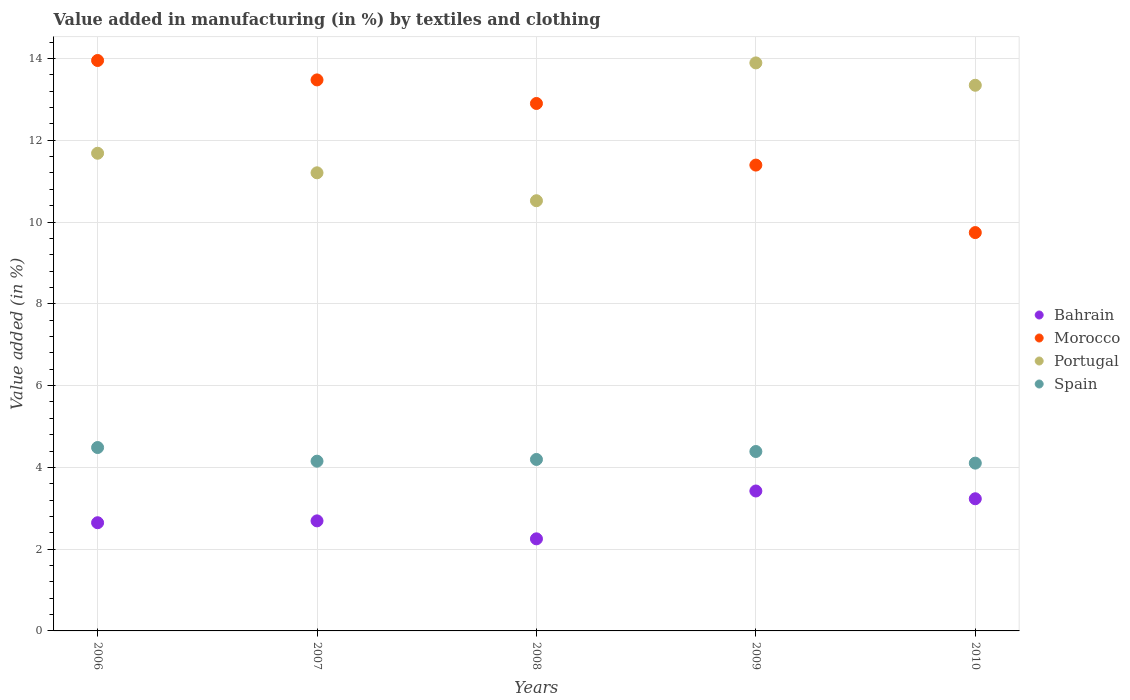Is the number of dotlines equal to the number of legend labels?
Provide a succinct answer. Yes. What is the percentage of value added in manufacturing by textiles and clothing in Portugal in 2009?
Ensure brevity in your answer.  13.89. Across all years, what is the maximum percentage of value added in manufacturing by textiles and clothing in Morocco?
Your answer should be very brief. 13.95. Across all years, what is the minimum percentage of value added in manufacturing by textiles and clothing in Morocco?
Offer a very short reply. 9.74. In which year was the percentage of value added in manufacturing by textiles and clothing in Bahrain maximum?
Give a very brief answer. 2009. In which year was the percentage of value added in manufacturing by textiles and clothing in Portugal minimum?
Your answer should be compact. 2008. What is the total percentage of value added in manufacturing by textiles and clothing in Spain in the graph?
Ensure brevity in your answer.  21.32. What is the difference between the percentage of value added in manufacturing by textiles and clothing in Bahrain in 2006 and that in 2009?
Your answer should be compact. -0.78. What is the difference between the percentage of value added in manufacturing by textiles and clothing in Spain in 2007 and the percentage of value added in manufacturing by textiles and clothing in Morocco in 2008?
Your answer should be very brief. -8.75. What is the average percentage of value added in manufacturing by textiles and clothing in Morocco per year?
Your response must be concise. 12.29. In the year 2006, what is the difference between the percentage of value added in manufacturing by textiles and clothing in Spain and percentage of value added in manufacturing by textiles and clothing in Morocco?
Provide a succinct answer. -9.46. In how many years, is the percentage of value added in manufacturing by textiles and clothing in Portugal greater than 5.2 %?
Offer a terse response. 5. What is the ratio of the percentage of value added in manufacturing by textiles and clothing in Portugal in 2008 to that in 2010?
Provide a succinct answer. 0.79. Is the percentage of value added in manufacturing by textiles and clothing in Bahrain in 2006 less than that in 2009?
Provide a succinct answer. Yes. What is the difference between the highest and the second highest percentage of value added in manufacturing by textiles and clothing in Morocco?
Offer a very short reply. 0.47. What is the difference between the highest and the lowest percentage of value added in manufacturing by textiles and clothing in Portugal?
Your answer should be compact. 3.37. Is it the case that in every year, the sum of the percentage of value added in manufacturing by textiles and clothing in Spain and percentage of value added in manufacturing by textiles and clothing in Portugal  is greater than the sum of percentage of value added in manufacturing by textiles and clothing in Bahrain and percentage of value added in manufacturing by textiles and clothing in Morocco?
Give a very brief answer. No. Does the percentage of value added in manufacturing by textiles and clothing in Bahrain monotonically increase over the years?
Provide a short and direct response. No. Is the percentage of value added in manufacturing by textiles and clothing in Spain strictly greater than the percentage of value added in manufacturing by textiles and clothing in Bahrain over the years?
Ensure brevity in your answer.  Yes. Does the graph contain grids?
Your answer should be compact. Yes. Where does the legend appear in the graph?
Your response must be concise. Center right. What is the title of the graph?
Provide a short and direct response. Value added in manufacturing (in %) by textiles and clothing. Does "Least developed countries" appear as one of the legend labels in the graph?
Provide a succinct answer. No. What is the label or title of the X-axis?
Make the answer very short. Years. What is the label or title of the Y-axis?
Your answer should be very brief. Value added (in %). What is the Value added (in %) in Bahrain in 2006?
Ensure brevity in your answer.  2.65. What is the Value added (in %) in Morocco in 2006?
Provide a short and direct response. 13.95. What is the Value added (in %) of Portugal in 2006?
Ensure brevity in your answer.  11.68. What is the Value added (in %) in Spain in 2006?
Your answer should be compact. 4.49. What is the Value added (in %) in Bahrain in 2007?
Ensure brevity in your answer.  2.69. What is the Value added (in %) in Morocco in 2007?
Keep it short and to the point. 13.48. What is the Value added (in %) in Portugal in 2007?
Make the answer very short. 11.2. What is the Value added (in %) of Spain in 2007?
Keep it short and to the point. 4.15. What is the Value added (in %) of Bahrain in 2008?
Offer a terse response. 2.25. What is the Value added (in %) in Morocco in 2008?
Your answer should be very brief. 12.9. What is the Value added (in %) of Portugal in 2008?
Offer a very short reply. 10.52. What is the Value added (in %) of Spain in 2008?
Your answer should be compact. 4.19. What is the Value added (in %) of Bahrain in 2009?
Your answer should be very brief. 3.42. What is the Value added (in %) in Morocco in 2009?
Offer a very short reply. 11.39. What is the Value added (in %) in Portugal in 2009?
Offer a terse response. 13.89. What is the Value added (in %) in Spain in 2009?
Your answer should be very brief. 4.39. What is the Value added (in %) in Bahrain in 2010?
Provide a succinct answer. 3.23. What is the Value added (in %) of Morocco in 2010?
Offer a very short reply. 9.74. What is the Value added (in %) of Portugal in 2010?
Make the answer very short. 13.34. What is the Value added (in %) in Spain in 2010?
Your answer should be very brief. 4.1. Across all years, what is the maximum Value added (in %) of Bahrain?
Make the answer very short. 3.42. Across all years, what is the maximum Value added (in %) of Morocco?
Offer a very short reply. 13.95. Across all years, what is the maximum Value added (in %) of Portugal?
Your answer should be compact. 13.89. Across all years, what is the maximum Value added (in %) in Spain?
Ensure brevity in your answer.  4.49. Across all years, what is the minimum Value added (in %) of Bahrain?
Make the answer very short. 2.25. Across all years, what is the minimum Value added (in %) in Morocco?
Offer a very short reply. 9.74. Across all years, what is the minimum Value added (in %) of Portugal?
Give a very brief answer. 10.52. Across all years, what is the minimum Value added (in %) of Spain?
Offer a terse response. 4.1. What is the total Value added (in %) in Bahrain in the graph?
Make the answer very short. 14.24. What is the total Value added (in %) in Morocco in the graph?
Offer a terse response. 61.46. What is the total Value added (in %) in Portugal in the graph?
Make the answer very short. 60.64. What is the total Value added (in %) in Spain in the graph?
Offer a very short reply. 21.32. What is the difference between the Value added (in %) of Bahrain in 2006 and that in 2007?
Provide a succinct answer. -0.05. What is the difference between the Value added (in %) in Morocco in 2006 and that in 2007?
Make the answer very short. 0.47. What is the difference between the Value added (in %) in Portugal in 2006 and that in 2007?
Your answer should be compact. 0.48. What is the difference between the Value added (in %) of Spain in 2006 and that in 2007?
Give a very brief answer. 0.33. What is the difference between the Value added (in %) of Bahrain in 2006 and that in 2008?
Offer a terse response. 0.39. What is the difference between the Value added (in %) of Morocco in 2006 and that in 2008?
Offer a terse response. 1.05. What is the difference between the Value added (in %) of Portugal in 2006 and that in 2008?
Offer a very short reply. 1.16. What is the difference between the Value added (in %) of Spain in 2006 and that in 2008?
Your answer should be compact. 0.29. What is the difference between the Value added (in %) of Bahrain in 2006 and that in 2009?
Your answer should be compact. -0.78. What is the difference between the Value added (in %) in Morocco in 2006 and that in 2009?
Give a very brief answer. 2.56. What is the difference between the Value added (in %) in Portugal in 2006 and that in 2009?
Your answer should be compact. -2.21. What is the difference between the Value added (in %) of Spain in 2006 and that in 2009?
Your response must be concise. 0.1. What is the difference between the Value added (in %) of Bahrain in 2006 and that in 2010?
Your answer should be compact. -0.59. What is the difference between the Value added (in %) in Morocco in 2006 and that in 2010?
Provide a succinct answer. 4.21. What is the difference between the Value added (in %) of Portugal in 2006 and that in 2010?
Your answer should be very brief. -1.66. What is the difference between the Value added (in %) of Spain in 2006 and that in 2010?
Ensure brevity in your answer.  0.38. What is the difference between the Value added (in %) in Bahrain in 2007 and that in 2008?
Offer a very short reply. 0.44. What is the difference between the Value added (in %) in Morocco in 2007 and that in 2008?
Offer a terse response. 0.58. What is the difference between the Value added (in %) of Portugal in 2007 and that in 2008?
Make the answer very short. 0.68. What is the difference between the Value added (in %) in Spain in 2007 and that in 2008?
Keep it short and to the point. -0.04. What is the difference between the Value added (in %) in Bahrain in 2007 and that in 2009?
Your response must be concise. -0.73. What is the difference between the Value added (in %) of Morocco in 2007 and that in 2009?
Provide a succinct answer. 2.08. What is the difference between the Value added (in %) in Portugal in 2007 and that in 2009?
Your answer should be very brief. -2.69. What is the difference between the Value added (in %) in Spain in 2007 and that in 2009?
Keep it short and to the point. -0.24. What is the difference between the Value added (in %) of Bahrain in 2007 and that in 2010?
Ensure brevity in your answer.  -0.54. What is the difference between the Value added (in %) of Morocco in 2007 and that in 2010?
Offer a terse response. 3.73. What is the difference between the Value added (in %) of Portugal in 2007 and that in 2010?
Provide a short and direct response. -2.14. What is the difference between the Value added (in %) in Spain in 2007 and that in 2010?
Your answer should be very brief. 0.05. What is the difference between the Value added (in %) in Bahrain in 2008 and that in 2009?
Provide a short and direct response. -1.17. What is the difference between the Value added (in %) in Morocco in 2008 and that in 2009?
Provide a succinct answer. 1.51. What is the difference between the Value added (in %) in Portugal in 2008 and that in 2009?
Ensure brevity in your answer.  -3.37. What is the difference between the Value added (in %) in Spain in 2008 and that in 2009?
Your response must be concise. -0.19. What is the difference between the Value added (in %) in Bahrain in 2008 and that in 2010?
Your answer should be compact. -0.98. What is the difference between the Value added (in %) of Morocco in 2008 and that in 2010?
Keep it short and to the point. 3.16. What is the difference between the Value added (in %) of Portugal in 2008 and that in 2010?
Make the answer very short. -2.82. What is the difference between the Value added (in %) in Spain in 2008 and that in 2010?
Your answer should be very brief. 0.09. What is the difference between the Value added (in %) of Bahrain in 2009 and that in 2010?
Ensure brevity in your answer.  0.19. What is the difference between the Value added (in %) of Morocco in 2009 and that in 2010?
Offer a very short reply. 1.65. What is the difference between the Value added (in %) of Portugal in 2009 and that in 2010?
Provide a short and direct response. 0.55. What is the difference between the Value added (in %) in Spain in 2009 and that in 2010?
Offer a very short reply. 0.28. What is the difference between the Value added (in %) in Bahrain in 2006 and the Value added (in %) in Morocco in 2007?
Ensure brevity in your answer.  -10.83. What is the difference between the Value added (in %) of Bahrain in 2006 and the Value added (in %) of Portugal in 2007?
Give a very brief answer. -8.56. What is the difference between the Value added (in %) in Bahrain in 2006 and the Value added (in %) in Spain in 2007?
Offer a terse response. -1.51. What is the difference between the Value added (in %) of Morocco in 2006 and the Value added (in %) of Portugal in 2007?
Your answer should be compact. 2.75. What is the difference between the Value added (in %) of Morocco in 2006 and the Value added (in %) of Spain in 2007?
Your answer should be very brief. 9.8. What is the difference between the Value added (in %) in Portugal in 2006 and the Value added (in %) in Spain in 2007?
Provide a short and direct response. 7.53. What is the difference between the Value added (in %) of Bahrain in 2006 and the Value added (in %) of Morocco in 2008?
Provide a short and direct response. -10.25. What is the difference between the Value added (in %) of Bahrain in 2006 and the Value added (in %) of Portugal in 2008?
Provide a succinct answer. -7.87. What is the difference between the Value added (in %) of Bahrain in 2006 and the Value added (in %) of Spain in 2008?
Your answer should be very brief. -1.55. What is the difference between the Value added (in %) in Morocco in 2006 and the Value added (in %) in Portugal in 2008?
Give a very brief answer. 3.43. What is the difference between the Value added (in %) of Morocco in 2006 and the Value added (in %) of Spain in 2008?
Provide a succinct answer. 9.76. What is the difference between the Value added (in %) of Portugal in 2006 and the Value added (in %) of Spain in 2008?
Keep it short and to the point. 7.49. What is the difference between the Value added (in %) of Bahrain in 2006 and the Value added (in %) of Morocco in 2009?
Ensure brevity in your answer.  -8.75. What is the difference between the Value added (in %) of Bahrain in 2006 and the Value added (in %) of Portugal in 2009?
Your response must be concise. -11.25. What is the difference between the Value added (in %) of Bahrain in 2006 and the Value added (in %) of Spain in 2009?
Ensure brevity in your answer.  -1.74. What is the difference between the Value added (in %) in Morocco in 2006 and the Value added (in %) in Portugal in 2009?
Make the answer very short. 0.06. What is the difference between the Value added (in %) in Morocco in 2006 and the Value added (in %) in Spain in 2009?
Offer a terse response. 9.56. What is the difference between the Value added (in %) of Portugal in 2006 and the Value added (in %) of Spain in 2009?
Ensure brevity in your answer.  7.29. What is the difference between the Value added (in %) in Bahrain in 2006 and the Value added (in %) in Morocco in 2010?
Keep it short and to the point. -7.1. What is the difference between the Value added (in %) of Bahrain in 2006 and the Value added (in %) of Portugal in 2010?
Your response must be concise. -10.7. What is the difference between the Value added (in %) in Bahrain in 2006 and the Value added (in %) in Spain in 2010?
Offer a very short reply. -1.46. What is the difference between the Value added (in %) of Morocco in 2006 and the Value added (in %) of Portugal in 2010?
Keep it short and to the point. 0.61. What is the difference between the Value added (in %) of Morocco in 2006 and the Value added (in %) of Spain in 2010?
Offer a terse response. 9.85. What is the difference between the Value added (in %) of Portugal in 2006 and the Value added (in %) of Spain in 2010?
Provide a short and direct response. 7.58. What is the difference between the Value added (in %) in Bahrain in 2007 and the Value added (in %) in Morocco in 2008?
Keep it short and to the point. -10.21. What is the difference between the Value added (in %) in Bahrain in 2007 and the Value added (in %) in Portugal in 2008?
Provide a succinct answer. -7.83. What is the difference between the Value added (in %) in Bahrain in 2007 and the Value added (in %) in Spain in 2008?
Ensure brevity in your answer.  -1.5. What is the difference between the Value added (in %) in Morocco in 2007 and the Value added (in %) in Portugal in 2008?
Provide a short and direct response. 2.95. What is the difference between the Value added (in %) of Morocco in 2007 and the Value added (in %) of Spain in 2008?
Your answer should be compact. 9.28. What is the difference between the Value added (in %) of Portugal in 2007 and the Value added (in %) of Spain in 2008?
Ensure brevity in your answer.  7.01. What is the difference between the Value added (in %) in Bahrain in 2007 and the Value added (in %) in Morocco in 2009?
Offer a very short reply. -8.7. What is the difference between the Value added (in %) in Bahrain in 2007 and the Value added (in %) in Portugal in 2009?
Your answer should be compact. -11.2. What is the difference between the Value added (in %) in Bahrain in 2007 and the Value added (in %) in Spain in 2009?
Your answer should be compact. -1.7. What is the difference between the Value added (in %) of Morocco in 2007 and the Value added (in %) of Portugal in 2009?
Your response must be concise. -0.42. What is the difference between the Value added (in %) of Morocco in 2007 and the Value added (in %) of Spain in 2009?
Keep it short and to the point. 9.09. What is the difference between the Value added (in %) in Portugal in 2007 and the Value added (in %) in Spain in 2009?
Offer a terse response. 6.82. What is the difference between the Value added (in %) of Bahrain in 2007 and the Value added (in %) of Morocco in 2010?
Keep it short and to the point. -7.05. What is the difference between the Value added (in %) in Bahrain in 2007 and the Value added (in %) in Portugal in 2010?
Provide a succinct answer. -10.65. What is the difference between the Value added (in %) in Bahrain in 2007 and the Value added (in %) in Spain in 2010?
Keep it short and to the point. -1.41. What is the difference between the Value added (in %) in Morocco in 2007 and the Value added (in %) in Portugal in 2010?
Provide a short and direct response. 0.13. What is the difference between the Value added (in %) of Morocco in 2007 and the Value added (in %) of Spain in 2010?
Provide a short and direct response. 9.37. What is the difference between the Value added (in %) in Portugal in 2007 and the Value added (in %) in Spain in 2010?
Keep it short and to the point. 7.1. What is the difference between the Value added (in %) of Bahrain in 2008 and the Value added (in %) of Morocco in 2009?
Give a very brief answer. -9.14. What is the difference between the Value added (in %) of Bahrain in 2008 and the Value added (in %) of Portugal in 2009?
Keep it short and to the point. -11.64. What is the difference between the Value added (in %) of Bahrain in 2008 and the Value added (in %) of Spain in 2009?
Provide a short and direct response. -2.14. What is the difference between the Value added (in %) of Morocco in 2008 and the Value added (in %) of Portugal in 2009?
Keep it short and to the point. -0.99. What is the difference between the Value added (in %) in Morocco in 2008 and the Value added (in %) in Spain in 2009?
Your answer should be very brief. 8.51. What is the difference between the Value added (in %) of Portugal in 2008 and the Value added (in %) of Spain in 2009?
Make the answer very short. 6.13. What is the difference between the Value added (in %) of Bahrain in 2008 and the Value added (in %) of Morocco in 2010?
Keep it short and to the point. -7.49. What is the difference between the Value added (in %) of Bahrain in 2008 and the Value added (in %) of Portugal in 2010?
Keep it short and to the point. -11.09. What is the difference between the Value added (in %) in Bahrain in 2008 and the Value added (in %) in Spain in 2010?
Ensure brevity in your answer.  -1.85. What is the difference between the Value added (in %) of Morocco in 2008 and the Value added (in %) of Portugal in 2010?
Your answer should be very brief. -0.45. What is the difference between the Value added (in %) of Morocco in 2008 and the Value added (in %) of Spain in 2010?
Offer a very short reply. 8.8. What is the difference between the Value added (in %) in Portugal in 2008 and the Value added (in %) in Spain in 2010?
Your answer should be very brief. 6.42. What is the difference between the Value added (in %) of Bahrain in 2009 and the Value added (in %) of Morocco in 2010?
Make the answer very short. -6.32. What is the difference between the Value added (in %) in Bahrain in 2009 and the Value added (in %) in Portugal in 2010?
Your response must be concise. -9.92. What is the difference between the Value added (in %) in Bahrain in 2009 and the Value added (in %) in Spain in 2010?
Give a very brief answer. -0.68. What is the difference between the Value added (in %) in Morocco in 2009 and the Value added (in %) in Portugal in 2010?
Provide a short and direct response. -1.95. What is the difference between the Value added (in %) in Morocco in 2009 and the Value added (in %) in Spain in 2010?
Offer a terse response. 7.29. What is the difference between the Value added (in %) in Portugal in 2009 and the Value added (in %) in Spain in 2010?
Give a very brief answer. 9.79. What is the average Value added (in %) of Bahrain per year?
Make the answer very short. 2.85. What is the average Value added (in %) in Morocco per year?
Your answer should be compact. 12.29. What is the average Value added (in %) in Portugal per year?
Your answer should be very brief. 12.13. What is the average Value added (in %) of Spain per year?
Offer a terse response. 4.26. In the year 2006, what is the difference between the Value added (in %) of Bahrain and Value added (in %) of Morocco?
Your answer should be compact. -11.3. In the year 2006, what is the difference between the Value added (in %) in Bahrain and Value added (in %) in Portugal?
Your answer should be very brief. -9.04. In the year 2006, what is the difference between the Value added (in %) of Bahrain and Value added (in %) of Spain?
Your answer should be compact. -1.84. In the year 2006, what is the difference between the Value added (in %) in Morocco and Value added (in %) in Portugal?
Keep it short and to the point. 2.27. In the year 2006, what is the difference between the Value added (in %) in Morocco and Value added (in %) in Spain?
Ensure brevity in your answer.  9.46. In the year 2006, what is the difference between the Value added (in %) in Portugal and Value added (in %) in Spain?
Provide a succinct answer. 7.2. In the year 2007, what is the difference between the Value added (in %) of Bahrain and Value added (in %) of Morocco?
Provide a succinct answer. -10.78. In the year 2007, what is the difference between the Value added (in %) in Bahrain and Value added (in %) in Portugal?
Provide a short and direct response. -8.51. In the year 2007, what is the difference between the Value added (in %) of Bahrain and Value added (in %) of Spain?
Keep it short and to the point. -1.46. In the year 2007, what is the difference between the Value added (in %) of Morocco and Value added (in %) of Portugal?
Your answer should be compact. 2.27. In the year 2007, what is the difference between the Value added (in %) in Morocco and Value added (in %) in Spain?
Give a very brief answer. 9.32. In the year 2007, what is the difference between the Value added (in %) in Portugal and Value added (in %) in Spain?
Make the answer very short. 7.05. In the year 2008, what is the difference between the Value added (in %) in Bahrain and Value added (in %) in Morocco?
Offer a very short reply. -10.65. In the year 2008, what is the difference between the Value added (in %) of Bahrain and Value added (in %) of Portugal?
Provide a succinct answer. -8.27. In the year 2008, what is the difference between the Value added (in %) in Bahrain and Value added (in %) in Spain?
Ensure brevity in your answer.  -1.94. In the year 2008, what is the difference between the Value added (in %) of Morocco and Value added (in %) of Portugal?
Keep it short and to the point. 2.38. In the year 2008, what is the difference between the Value added (in %) of Morocco and Value added (in %) of Spain?
Offer a very short reply. 8.71. In the year 2008, what is the difference between the Value added (in %) of Portugal and Value added (in %) of Spain?
Ensure brevity in your answer.  6.33. In the year 2009, what is the difference between the Value added (in %) in Bahrain and Value added (in %) in Morocco?
Give a very brief answer. -7.97. In the year 2009, what is the difference between the Value added (in %) of Bahrain and Value added (in %) of Portugal?
Provide a succinct answer. -10.47. In the year 2009, what is the difference between the Value added (in %) in Bahrain and Value added (in %) in Spain?
Your answer should be very brief. -0.97. In the year 2009, what is the difference between the Value added (in %) of Morocco and Value added (in %) of Portugal?
Make the answer very short. -2.5. In the year 2009, what is the difference between the Value added (in %) in Morocco and Value added (in %) in Spain?
Offer a terse response. 7. In the year 2009, what is the difference between the Value added (in %) of Portugal and Value added (in %) of Spain?
Your answer should be very brief. 9.5. In the year 2010, what is the difference between the Value added (in %) of Bahrain and Value added (in %) of Morocco?
Provide a short and direct response. -6.51. In the year 2010, what is the difference between the Value added (in %) of Bahrain and Value added (in %) of Portugal?
Provide a short and direct response. -10.11. In the year 2010, what is the difference between the Value added (in %) of Bahrain and Value added (in %) of Spain?
Your answer should be very brief. -0.87. In the year 2010, what is the difference between the Value added (in %) in Morocco and Value added (in %) in Portugal?
Your answer should be compact. -3.6. In the year 2010, what is the difference between the Value added (in %) in Morocco and Value added (in %) in Spain?
Your response must be concise. 5.64. In the year 2010, what is the difference between the Value added (in %) in Portugal and Value added (in %) in Spain?
Keep it short and to the point. 9.24. What is the ratio of the Value added (in %) in Bahrain in 2006 to that in 2007?
Provide a short and direct response. 0.98. What is the ratio of the Value added (in %) of Morocco in 2006 to that in 2007?
Offer a terse response. 1.04. What is the ratio of the Value added (in %) of Portugal in 2006 to that in 2007?
Provide a short and direct response. 1.04. What is the ratio of the Value added (in %) of Spain in 2006 to that in 2007?
Keep it short and to the point. 1.08. What is the ratio of the Value added (in %) of Bahrain in 2006 to that in 2008?
Provide a short and direct response. 1.17. What is the ratio of the Value added (in %) of Morocco in 2006 to that in 2008?
Offer a terse response. 1.08. What is the ratio of the Value added (in %) in Portugal in 2006 to that in 2008?
Provide a succinct answer. 1.11. What is the ratio of the Value added (in %) of Spain in 2006 to that in 2008?
Keep it short and to the point. 1.07. What is the ratio of the Value added (in %) in Bahrain in 2006 to that in 2009?
Offer a very short reply. 0.77. What is the ratio of the Value added (in %) in Morocco in 2006 to that in 2009?
Your answer should be compact. 1.22. What is the ratio of the Value added (in %) in Portugal in 2006 to that in 2009?
Your response must be concise. 0.84. What is the ratio of the Value added (in %) in Spain in 2006 to that in 2009?
Ensure brevity in your answer.  1.02. What is the ratio of the Value added (in %) in Bahrain in 2006 to that in 2010?
Offer a terse response. 0.82. What is the ratio of the Value added (in %) in Morocco in 2006 to that in 2010?
Give a very brief answer. 1.43. What is the ratio of the Value added (in %) in Portugal in 2006 to that in 2010?
Your response must be concise. 0.88. What is the ratio of the Value added (in %) of Spain in 2006 to that in 2010?
Provide a succinct answer. 1.09. What is the ratio of the Value added (in %) of Bahrain in 2007 to that in 2008?
Make the answer very short. 1.2. What is the ratio of the Value added (in %) of Morocco in 2007 to that in 2008?
Provide a short and direct response. 1.04. What is the ratio of the Value added (in %) in Portugal in 2007 to that in 2008?
Ensure brevity in your answer.  1.06. What is the ratio of the Value added (in %) in Spain in 2007 to that in 2008?
Offer a terse response. 0.99. What is the ratio of the Value added (in %) of Bahrain in 2007 to that in 2009?
Give a very brief answer. 0.79. What is the ratio of the Value added (in %) of Morocco in 2007 to that in 2009?
Your answer should be compact. 1.18. What is the ratio of the Value added (in %) of Portugal in 2007 to that in 2009?
Provide a short and direct response. 0.81. What is the ratio of the Value added (in %) in Spain in 2007 to that in 2009?
Make the answer very short. 0.95. What is the ratio of the Value added (in %) in Bahrain in 2007 to that in 2010?
Your answer should be very brief. 0.83. What is the ratio of the Value added (in %) of Morocco in 2007 to that in 2010?
Your answer should be compact. 1.38. What is the ratio of the Value added (in %) of Portugal in 2007 to that in 2010?
Your response must be concise. 0.84. What is the ratio of the Value added (in %) of Spain in 2007 to that in 2010?
Your answer should be compact. 1.01. What is the ratio of the Value added (in %) of Bahrain in 2008 to that in 2009?
Provide a short and direct response. 0.66. What is the ratio of the Value added (in %) in Morocco in 2008 to that in 2009?
Keep it short and to the point. 1.13. What is the ratio of the Value added (in %) in Portugal in 2008 to that in 2009?
Ensure brevity in your answer.  0.76. What is the ratio of the Value added (in %) of Spain in 2008 to that in 2009?
Provide a short and direct response. 0.96. What is the ratio of the Value added (in %) of Bahrain in 2008 to that in 2010?
Your answer should be compact. 0.7. What is the ratio of the Value added (in %) of Morocco in 2008 to that in 2010?
Your response must be concise. 1.32. What is the ratio of the Value added (in %) of Portugal in 2008 to that in 2010?
Provide a short and direct response. 0.79. What is the ratio of the Value added (in %) in Spain in 2008 to that in 2010?
Provide a succinct answer. 1.02. What is the ratio of the Value added (in %) in Bahrain in 2009 to that in 2010?
Keep it short and to the point. 1.06. What is the ratio of the Value added (in %) in Morocco in 2009 to that in 2010?
Your response must be concise. 1.17. What is the ratio of the Value added (in %) in Portugal in 2009 to that in 2010?
Keep it short and to the point. 1.04. What is the ratio of the Value added (in %) of Spain in 2009 to that in 2010?
Make the answer very short. 1.07. What is the difference between the highest and the second highest Value added (in %) of Bahrain?
Your answer should be compact. 0.19. What is the difference between the highest and the second highest Value added (in %) of Morocco?
Give a very brief answer. 0.47. What is the difference between the highest and the second highest Value added (in %) of Portugal?
Provide a short and direct response. 0.55. What is the difference between the highest and the second highest Value added (in %) in Spain?
Give a very brief answer. 0.1. What is the difference between the highest and the lowest Value added (in %) in Bahrain?
Your answer should be compact. 1.17. What is the difference between the highest and the lowest Value added (in %) of Morocco?
Ensure brevity in your answer.  4.21. What is the difference between the highest and the lowest Value added (in %) of Portugal?
Make the answer very short. 3.37. What is the difference between the highest and the lowest Value added (in %) of Spain?
Offer a very short reply. 0.38. 